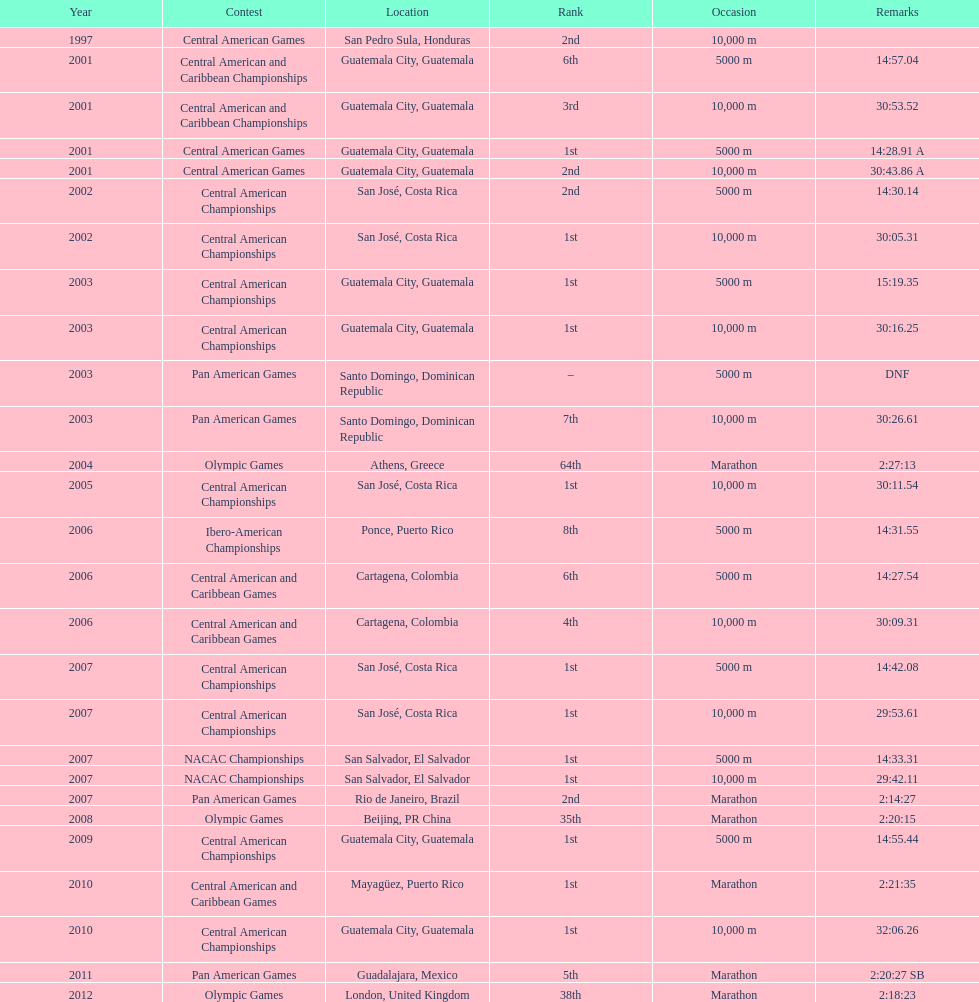What was the last competition in which a position of "2nd" was achieved? Pan American Games. 